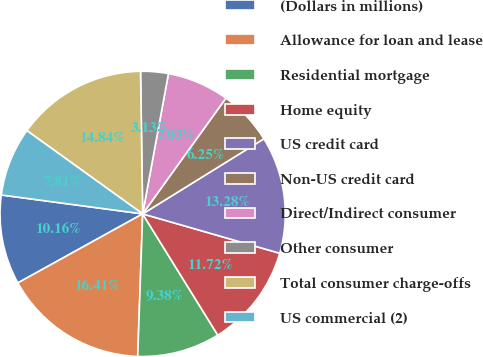Convert chart. <chart><loc_0><loc_0><loc_500><loc_500><pie_chart><fcel>(Dollars in millions)<fcel>Allowance for loan and lease<fcel>Residential mortgage<fcel>Home equity<fcel>US credit card<fcel>Non-US credit card<fcel>Direct/Indirect consumer<fcel>Other consumer<fcel>Total consumer charge-offs<fcel>US commercial (2)<nl><fcel>10.16%<fcel>16.41%<fcel>9.38%<fcel>11.72%<fcel>13.28%<fcel>6.25%<fcel>7.03%<fcel>3.13%<fcel>14.84%<fcel>7.81%<nl></chart> 